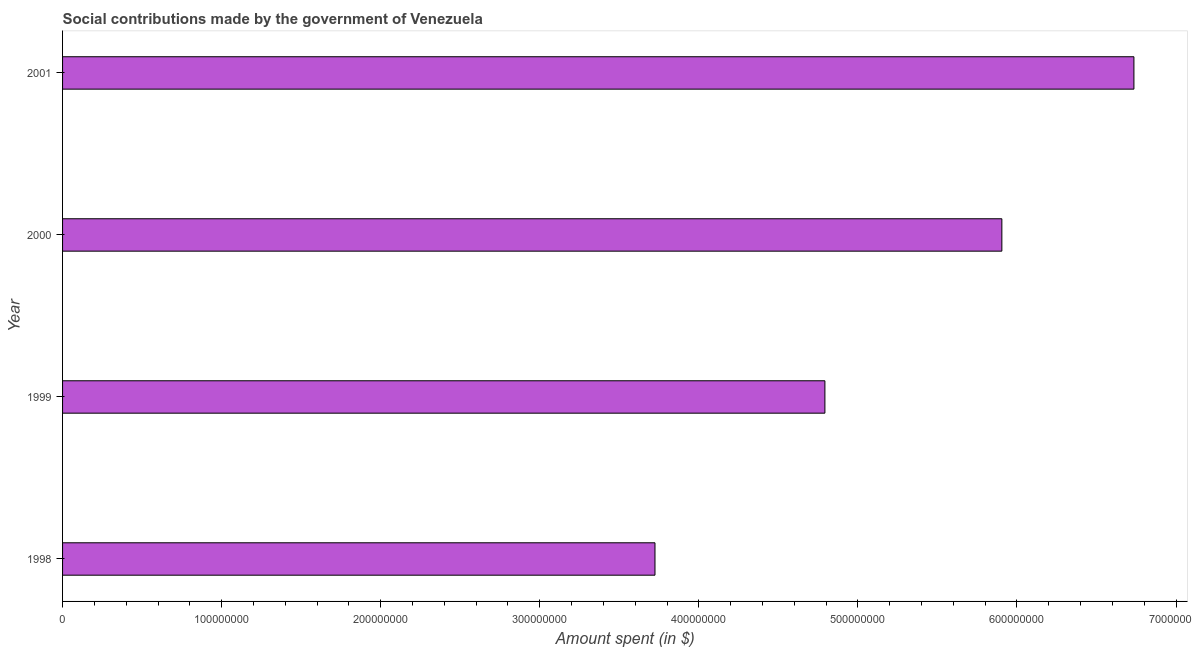Does the graph contain any zero values?
Ensure brevity in your answer.  No. What is the title of the graph?
Your answer should be very brief. Social contributions made by the government of Venezuela. What is the label or title of the X-axis?
Offer a very short reply. Amount spent (in $). What is the label or title of the Y-axis?
Your answer should be very brief. Year. What is the amount spent in making social contributions in 1998?
Give a very brief answer. 3.72e+08. Across all years, what is the maximum amount spent in making social contributions?
Provide a succinct answer. 6.74e+08. Across all years, what is the minimum amount spent in making social contributions?
Ensure brevity in your answer.  3.72e+08. In which year was the amount spent in making social contributions maximum?
Your answer should be compact. 2001. What is the sum of the amount spent in making social contributions?
Make the answer very short. 2.12e+09. What is the difference between the amount spent in making social contributions in 2000 and 2001?
Ensure brevity in your answer.  -8.30e+07. What is the average amount spent in making social contributions per year?
Your response must be concise. 5.29e+08. What is the median amount spent in making social contributions?
Your answer should be compact. 5.35e+08. Do a majority of the years between 1998 and 2000 (inclusive) have amount spent in making social contributions greater than 60000000 $?
Your answer should be very brief. Yes. What is the ratio of the amount spent in making social contributions in 1999 to that in 2001?
Your answer should be compact. 0.71. Is the difference between the amount spent in making social contributions in 1999 and 2001 greater than the difference between any two years?
Your response must be concise. No. What is the difference between the highest and the second highest amount spent in making social contributions?
Make the answer very short. 8.30e+07. What is the difference between the highest and the lowest amount spent in making social contributions?
Provide a succinct answer. 3.01e+08. In how many years, is the amount spent in making social contributions greater than the average amount spent in making social contributions taken over all years?
Offer a terse response. 2. What is the difference between two consecutive major ticks on the X-axis?
Provide a succinct answer. 1.00e+08. Are the values on the major ticks of X-axis written in scientific E-notation?
Your answer should be very brief. No. What is the Amount spent (in $) of 1998?
Your answer should be very brief. 3.72e+08. What is the Amount spent (in $) of 1999?
Provide a short and direct response. 4.79e+08. What is the Amount spent (in $) in 2000?
Provide a succinct answer. 5.91e+08. What is the Amount spent (in $) in 2001?
Make the answer very short. 6.74e+08. What is the difference between the Amount spent (in $) in 1998 and 1999?
Your answer should be very brief. -1.07e+08. What is the difference between the Amount spent (in $) in 1998 and 2000?
Make the answer very short. -2.18e+08. What is the difference between the Amount spent (in $) in 1998 and 2001?
Your answer should be compact. -3.01e+08. What is the difference between the Amount spent (in $) in 1999 and 2000?
Provide a short and direct response. -1.11e+08. What is the difference between the Amount spent (in $) in 1999 and 2001?
Offer a terse response. -1.94e+08. What is the difference between the Amount spent (in $) in 2000 and 2001?
Provide a short and direct response. -8.30e+07. What is the ratio of the Amount spent (in $) in 1998 to that in 1999?
Keep it short and to the point. 0.78. What is the ratio of the Amount spent (in $) in 1998 to that in 2000?
Make the answer very short. 0.63. What is the ratio of the Amount spent (in $) in 1998 to that in 2001?
Provide a short and direct response. 0.55. What is the ratio of the Amount spent (in $) in 1999 to that in 2000?
Make the answer very short. 0.81. What is the ratio of the Amount spent (in $) in 1999 to that in 2001?
Offer a very short reply. 0.71. What is the ratio of the Amount spent (in $) in 2000 to that in 2001?
Offer a very short reply. 0.88. 